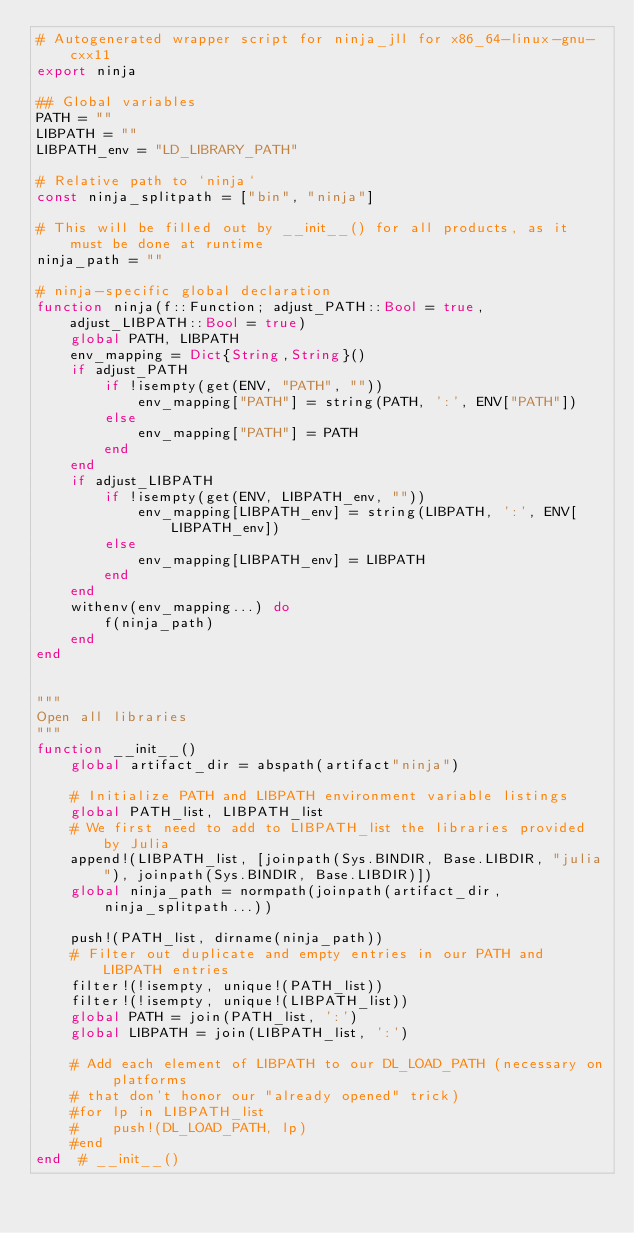<code> <loc_0><loc_0><loc_500><loc_500><_Julia_># Autogenerated wrapper script for ninja_jll for x86_64-linux-gnu-cxx11
export ninja

## Global variables
PATH = ""
LIBPATH = ""
LIBPATH_env = "LD_LIBRARY_PATH"

# Relative path to `ninja`
const ninja_splitpath = ["bin", "ninja"]

# This will be filled out by __init__() for all products, as it must be done at runtime
ninja_path = ""

# ninja-specific global declaration
function ninja(f::Function; adjust_PATH::Bool = true, adjust_LIBPATH::Bool = true)
    global PATH, LIBPATH
    env_mapping = Dict{String,String}()
    if adjust_PATH
        if !isempty(get(ENV, "PATH", ""))
            env_mapping["PATH"] = string(PATH, ':', ENV["PATH"])
        else
            env_mapping["PATH"] = PATH
        end
    end
    if adjust_LIBPATH
        if !isempty(get(ENV, LIBPATH_env, ""))
            env_mapping[LIBPATH_env] = string(LIBPATH, ':', ENV[LIBPATH_env])
        else
            env_mapping[LIBPATH_env] = LIBPATH
        end
    end
    withenv(env_mapping...) do
        f(ninja_path)
    end
end


"""
Open all libraries
"""
function __init__()
    global artifact_dir = abspath(artifact"ninja")

    # Initialize PATH and LIBPATH environment variable listings
    global PATH_list, LIBPATH_list
    # We first need to add to LIBPATH_list the libraries provided by Julia
    append!(LIBPATH_list, [joinpath(Sys.BINDIR, Base.LIBDIR, "julia"), joinpath(Sys.BINDIR, Base.LIBDIR)])
    global ninja_path = normpath(joinpath(artifact_dir, ninja_splitpath...))

    push!(PATH_list, dirname(ninja_path))
    # Filter out duplicate and empty entries in our PATH and LIBPATH entries
    filter!(!isempty, unique!(PATH_list))
    filter!(!isempty, unique!(LIBPATH_list))
    global PATH = join(PATH_list, ':')
    global LIBPATH = join(LIBPATH_list, ':')

    # Add each element of LIBPATH to our DL_LOAD_PATH (necessary on platforms
    # that don't honor our "already opened" trick)
    #for lp in LIBPATH_list
    #    push!(DL_LOAD_PATH, lp)
    #end
end  # __init__()

</code> 